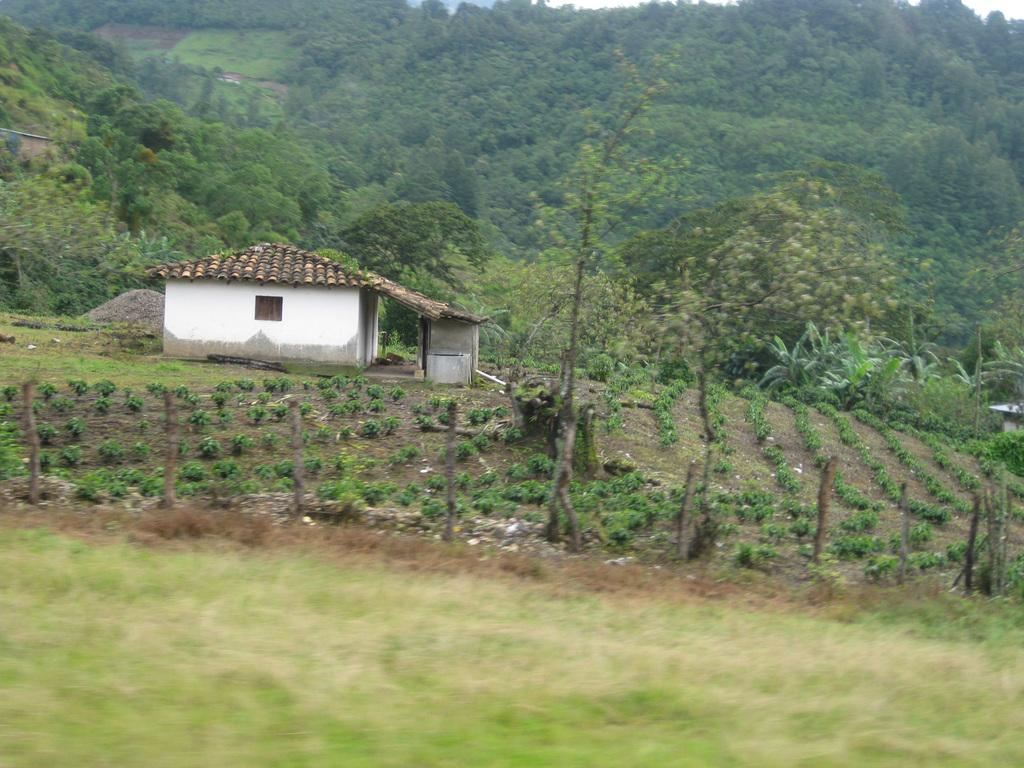What type of structure is present in the image? There is a building in the image. What type of vegetation can be seen in the image? There are shrubs, trees, and wooden fences in the image. What type of landscape feature is present in the image? There are hills in the image. What part of the natural environment is visible in the image? The sky is visible in the image. What type of card is being used by the achiever in the image? There is no card or achiever present in the image. 